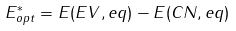Convert formula to latex. <formula><loc_0><loc_0><loc_500><loc_500>E _ { o p t } ^ { * } = E ( E V , e q ) - E ( C N , e q )</formula> 